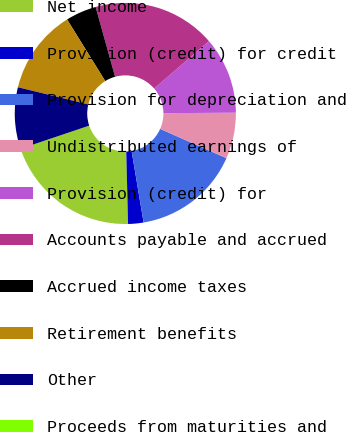Convert chart. <chart><loc_0><loc_0><loc_500><loc_500><pie_chart><fcel>Net income<fcel>Provision (credit) for credit<fcel>Provision for depreciation and<fcel>Undistributed earnings of<fcel>Provision (credit) for<fcel>Accounts payable and accrued<fcel>Accrued income taxes<fcel>Retirement benefits<fcel>Other<fcel>Proceeds from maturities and<nl><fcel>20.22%<fcel>2.25%<fcel>15.73%<fcel>6.74%<fcel>11.24%<fcel>17.98%<fcel>4.5%<fcel>12.36%<fcel>8.99%<fcel>0.0%<nl></chart> 